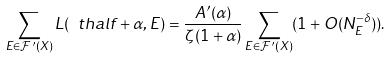Convert formula to latex. <formula><loc_0><loc_0><loc_500><loc_500>\sum _ { E \in \mathcal { F } ^ { \prime } ( X ) } L ( \ t h a l f + \alpha , E ) = \frac { A ^ { \prime } ( \alpha ) } { \zeta ( 1 + \alpha ) } \sum _ { E \in \mathcal { F } ^ { \prime } ( X ) } ( 1 + O ( N _ { E } ^ { - \delta } ) ) .</formula> 